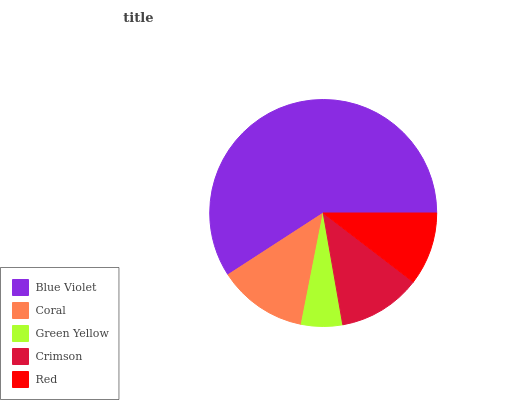Is Green Yellow the minimum?
Answer yes or no. Yes. Is Blue Violet the maximum?
Answer yes or no. Yes. Is Coral the minimum?
Answer yes or no. No. Is Coral the maximum?
Answer yes or no. No. Is Blue Violet greater than Coral?
Answer yes or no. Yes. Is Coral less than Blue Violet?
Answer yes or no. Yes. Is Coral greater than Blue Violet?
Answer yes or no. No. Is Blue Violet less than Coral?
Answer yes or no. No. Is Crimson the high median?
Answer yes or no. Yes. Is Crimson the low median?
Answer yes or no. Yes. Is Blue Violet the high median?
Answer yes or no. No. Is Blue Violet the low median?
Answer yes or no. No. 